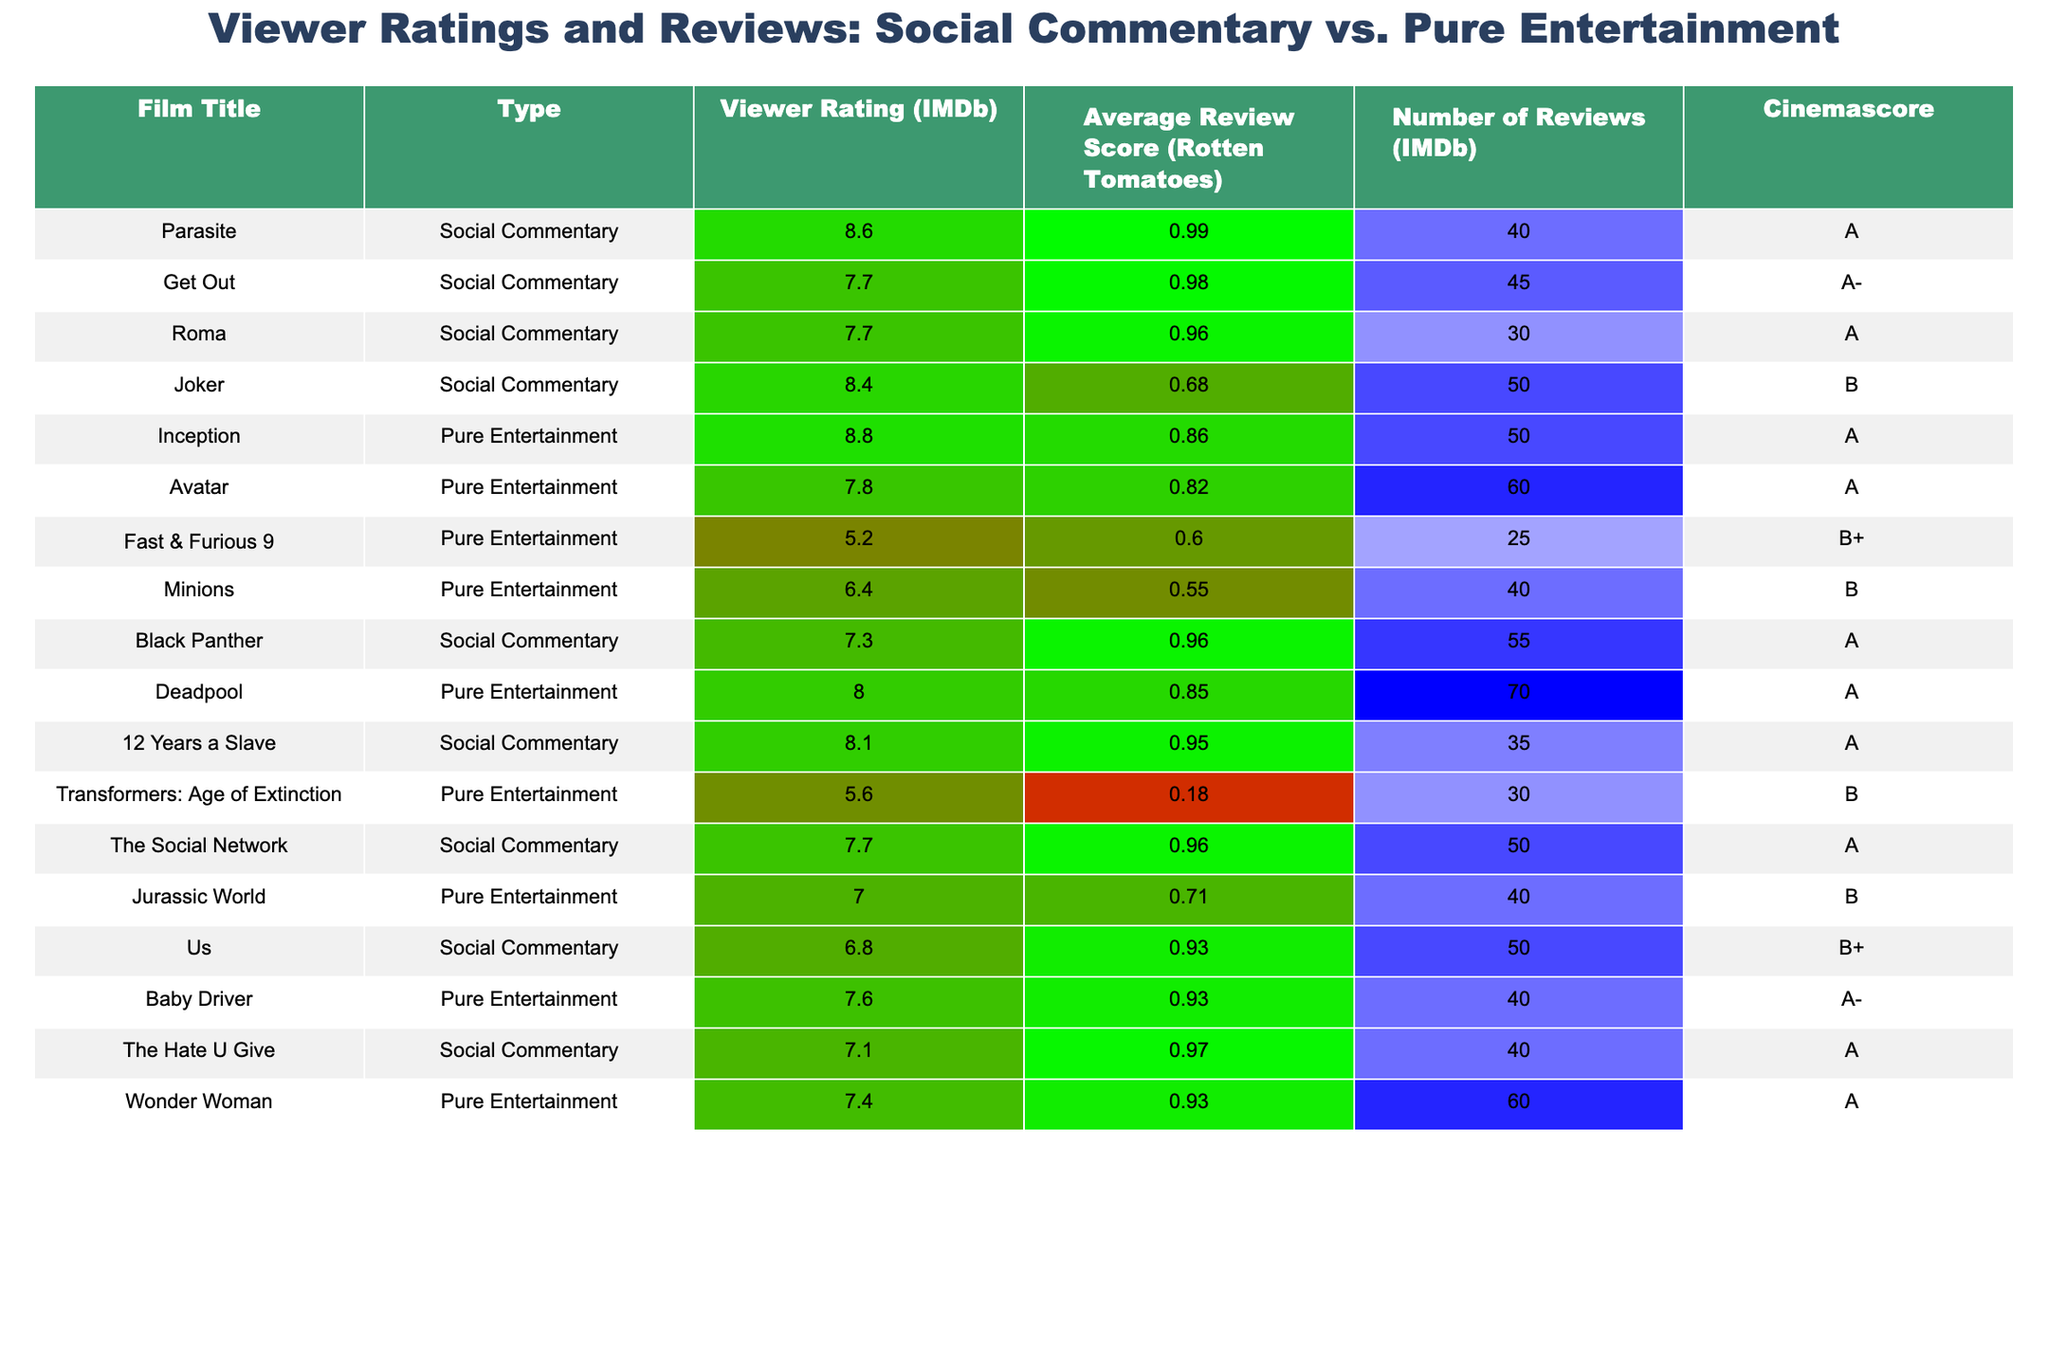What is the highest viewer rating for a film with social commentary? The table shows "Parasite" with a viewer rating of 8.6, which is the highest among films categorized as social commentary.
Answer: 8.6 Which pure entertainment film has the lowest average review score? The table indicates that "Transformers: Age of Extinction" has the lowest average review score at 18%, making it the lowest in the pure entertainment category.
Answer: 18% What is the average viewer rating for films with social commentary? Adding the viewer ratings for social commentary films: (8.6 + 7.7 + 7.7 + 8.4 + 7.3 + 8.1 + 6.8 + 7.1) = 63.7. Dividing by the 8 films gives an average rating of 63.7 / 8 = 7.96.
Answer: 7.96 Which film has the highest number of reviews on IMDb and what is its type? "Deadpool" has the highest number of reviews on IMDb with 70, and it falls under the pure entertainment type.
Answer: Deadpool, Pure Entertainment Do any films with social commentary have a cinema score of B or lower? Yes, "Joker" has a cinema score of B, which is the only film with social commentary that has this score or lower.
Answer: Yes What is the total number of reviews for pure entertainment films? Summing the number of reviews for pure entertainment films: (50 + 60 + 25 + 40 + 70 + 30 + 40) = 305.
Answer: 305 How many films in the table have an average review score of over 90%? The films with an average review score over 90% are "Parasite," "Get Out," "Roma," "Black Panther," "12 Years a Slave," and "The Hate U Give." There are 6 films in total.
Answer: 6 Is there a film type that has an overall higher average viewer rating? For social commentary films, the average viewer rating is 7.96, while for pure entertainment films it is 7.67 (average calculated as (8.8 + 7.8 + 5.2 + 6.4 + 8 + 5.6 + 7 + 7.6 + 7.4) / 9 = 7.67). Thus, social commentary has a higher average viewer rating.
Answer: Yes, social commentary What is the difference in viewer ratings between the highest-rated social commentary film and the highest-rated pure entertainment film? The highest-rated social commentary film "Parasite" has a rating of 8.6, and the highest-rated pure entertainment film "Inception" has a rating of 8.8. The difference is 8.8 - 8.6 = 0.2.
Answer: 0.2 What percentage of social commentary films received an 'A' or 'A-' cinema score? There are 5 social commentary films, with "Parasite," "Get Out," "12 Years a Slave," and "The Social Network" receiving A/A- grades. Thus, 4 out of 5 films = 80%.
Answer: 80% 